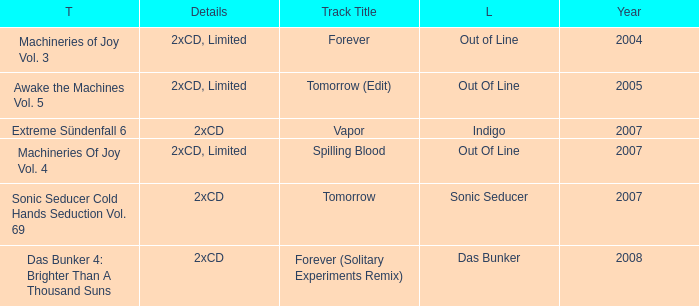What average year contains the title of machineries of joy vol. 4? 2007.0. 